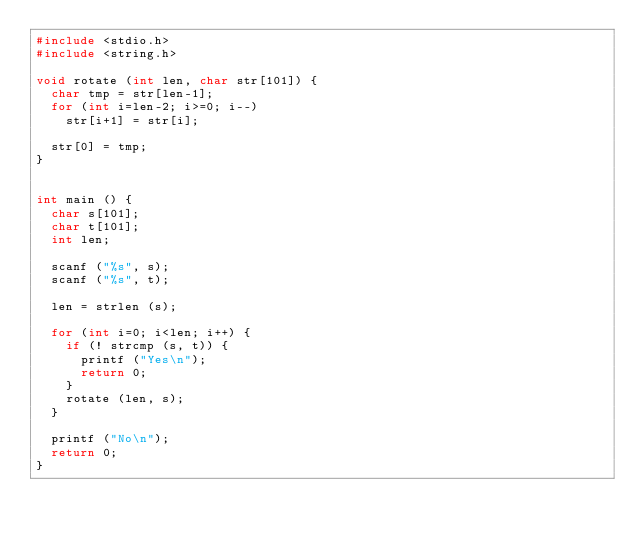Convert code to text. <code><loc_0><loc_0><loc_500><loc_500><_C_>#include <stdio.h>
#include <string.h>

void rotate (int len, char str[101]) {
	char tmp = str[len-1];
	for (int i=len-2; i>=0; i--)
		str[i+1] = str[i];

	str[0] = tmp;
}


int main () {
	char s[101];
	char t[101];
	int len;

	scanf ("%s", s);
	scanf ("%s", t);

	len = strlen (s);

	for (int i=0; i<len; i++) {
		if (! strcmp (s, t)) {
			printf ("Yes\n");
			return 0;
		}
		rotate (len, s);
	}

	printf ("No\n");
	return 0;
}
</code> 